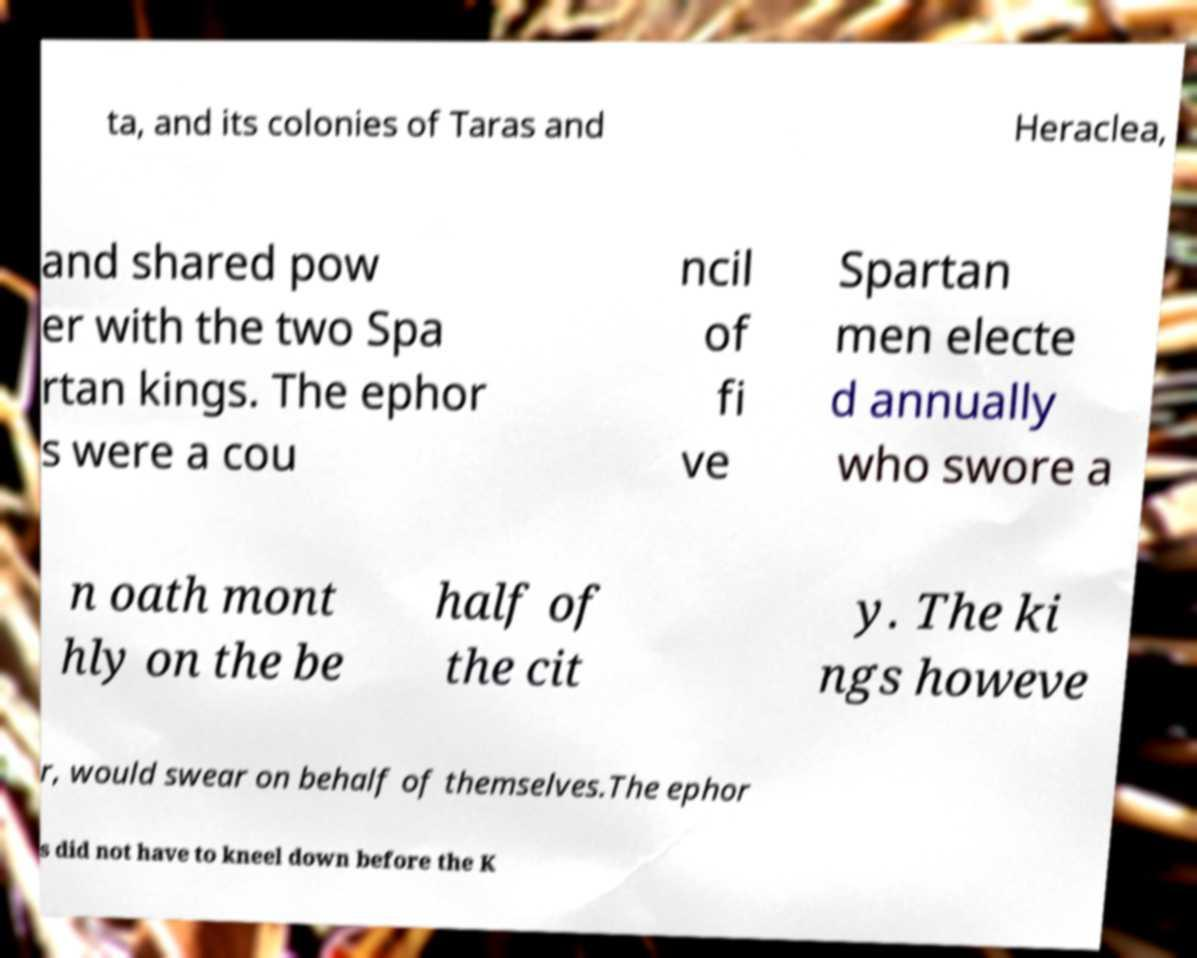There's text embedded in this image that I need extracted. Can you transcribe it verbatim? ta, and its colonies of Taras and Heraclea, and shared pow er with the two Spa rtan kings. The ephor s were a cou ncil of fi ve Spartan men electe d annually who swore a n oath mont hly on the be half of the cit y. The ki ngs howeve r, would swear on behalf of themselves.The ephor s did not have to kneel down before the K 